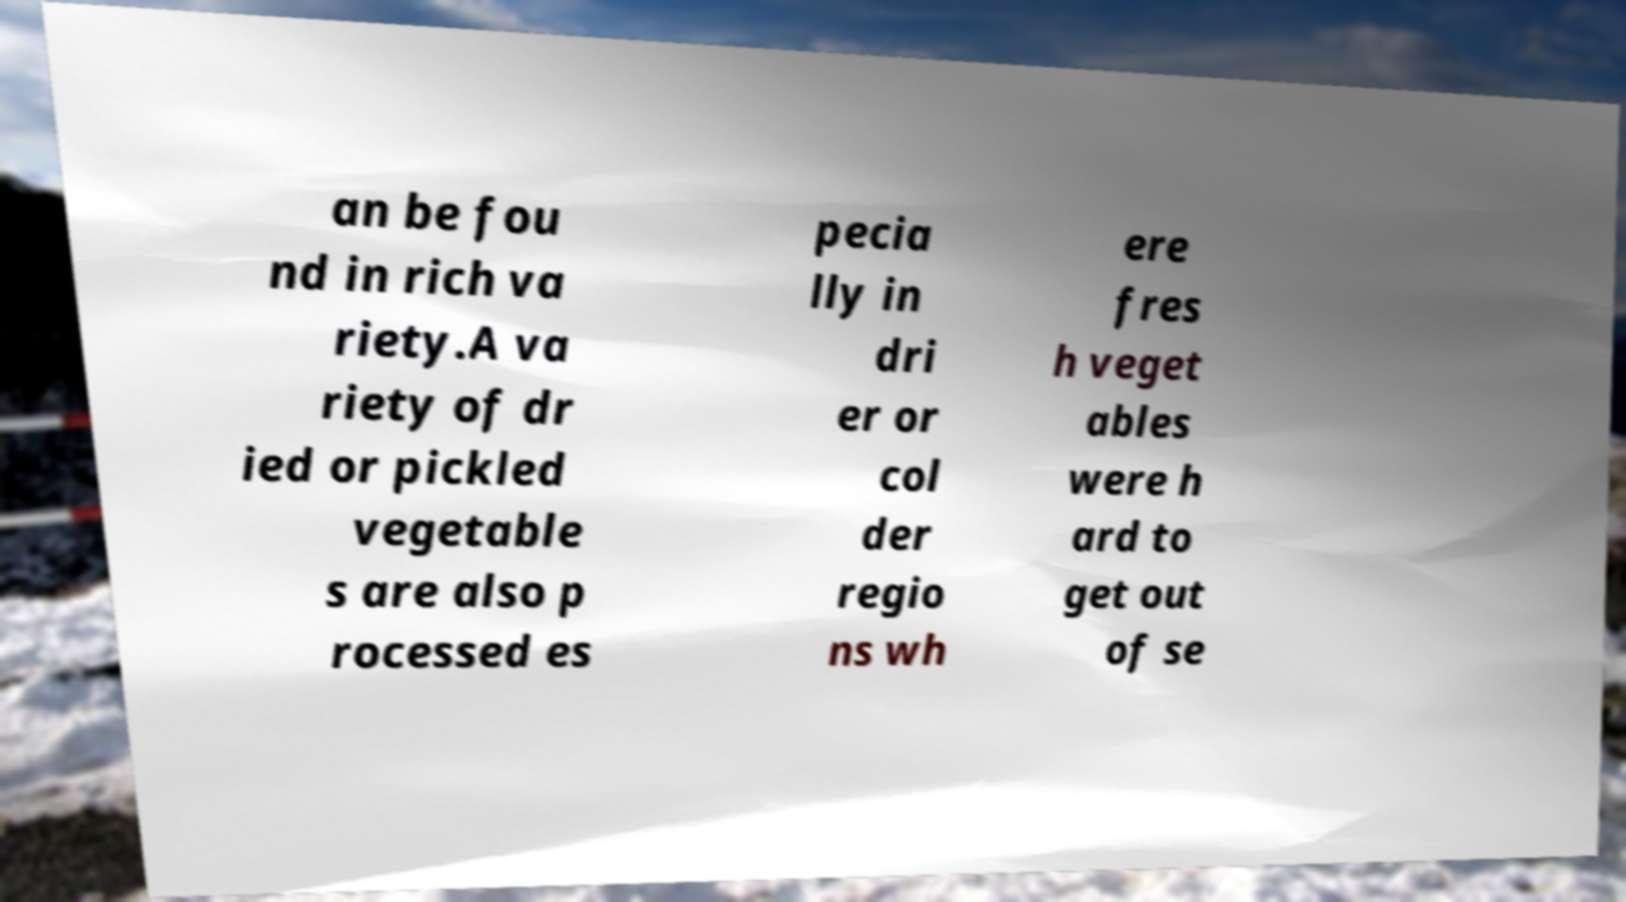Please read and relay the text visible in this image. What does it say? an be fou nd in rich va riety.A va riety of dr ied or pickled vegetable s are also p rocessed es pecia lly in dri er or col der regio ns wh ere fres h veget ables were h ard to get out of se 